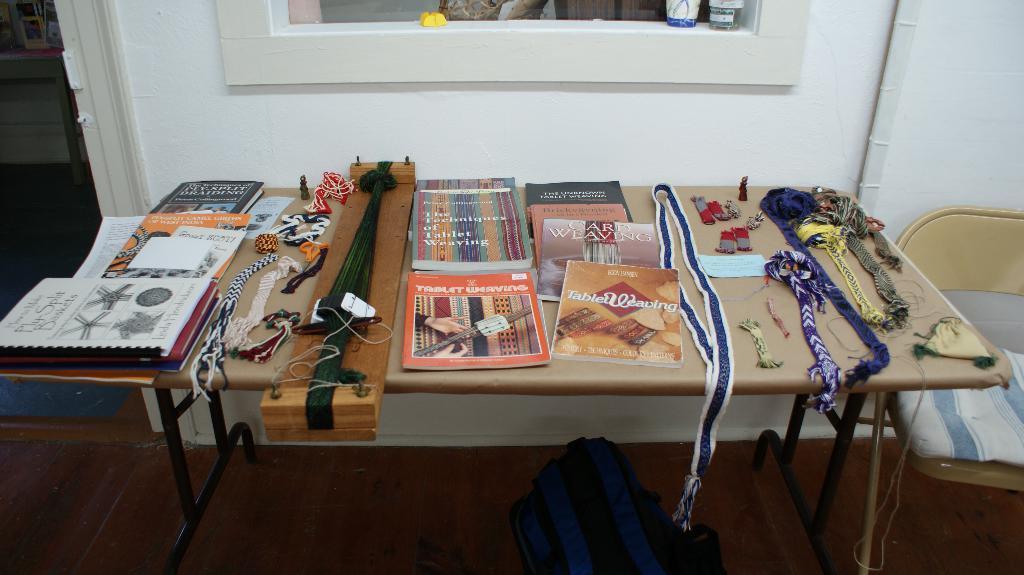Please provide a concise description of this image. This picture shows a table on which some books, threads and some accessories were replaced. Under the table, there is a bag on the floor. Beside the table, there is a chair and in the background we can observe a wall here. 